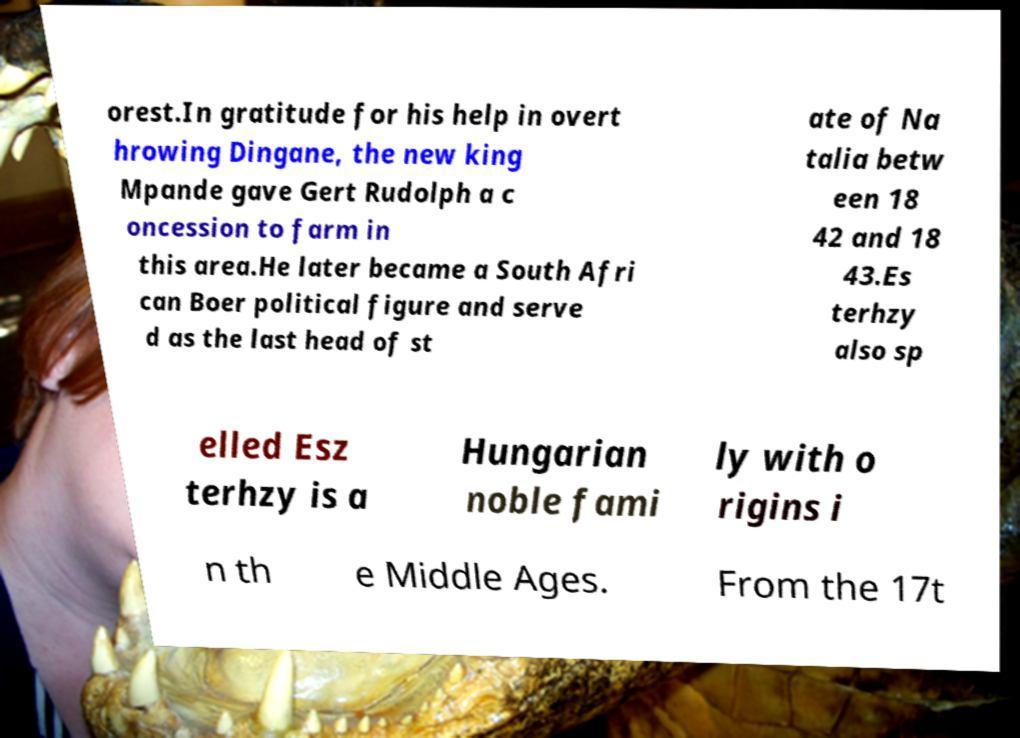Could you extract and type out the text from this image? orest.In gratitude for his help in overt hrowing Dingane, the new king Mpande gave Gert Rudolph a c oncession to farm in this area.He later became a South Afri can Boer political figure and serve d as the last head of st ate of Na talia betw een 18 42 and 18 43.Es terhzy also sp elled Esz terhzy is a Hungarian noble fami ly with o rigins i n th e Middle Ages. From the 17t 